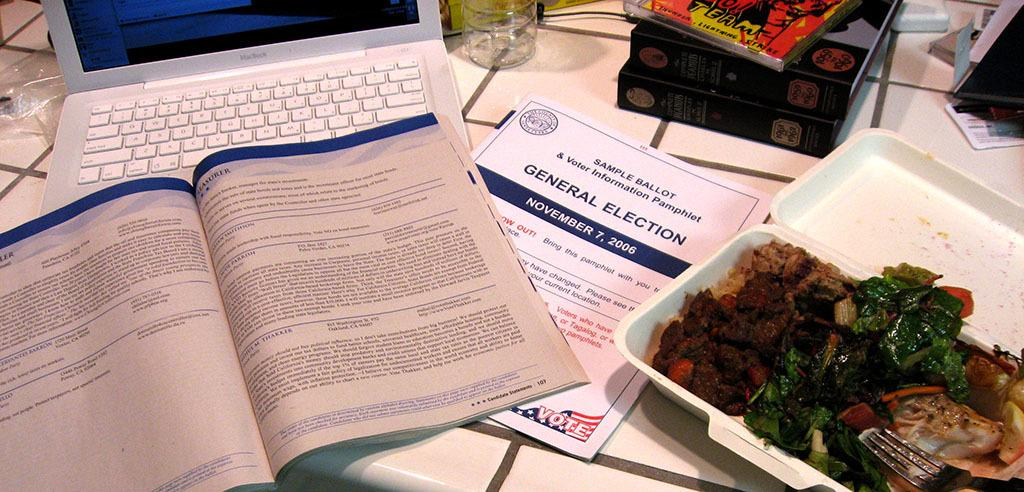Provide a one-sentence caption for the provided image. A booklet that says General Election on it sits on a table beside a laptop and other pamphlets. 